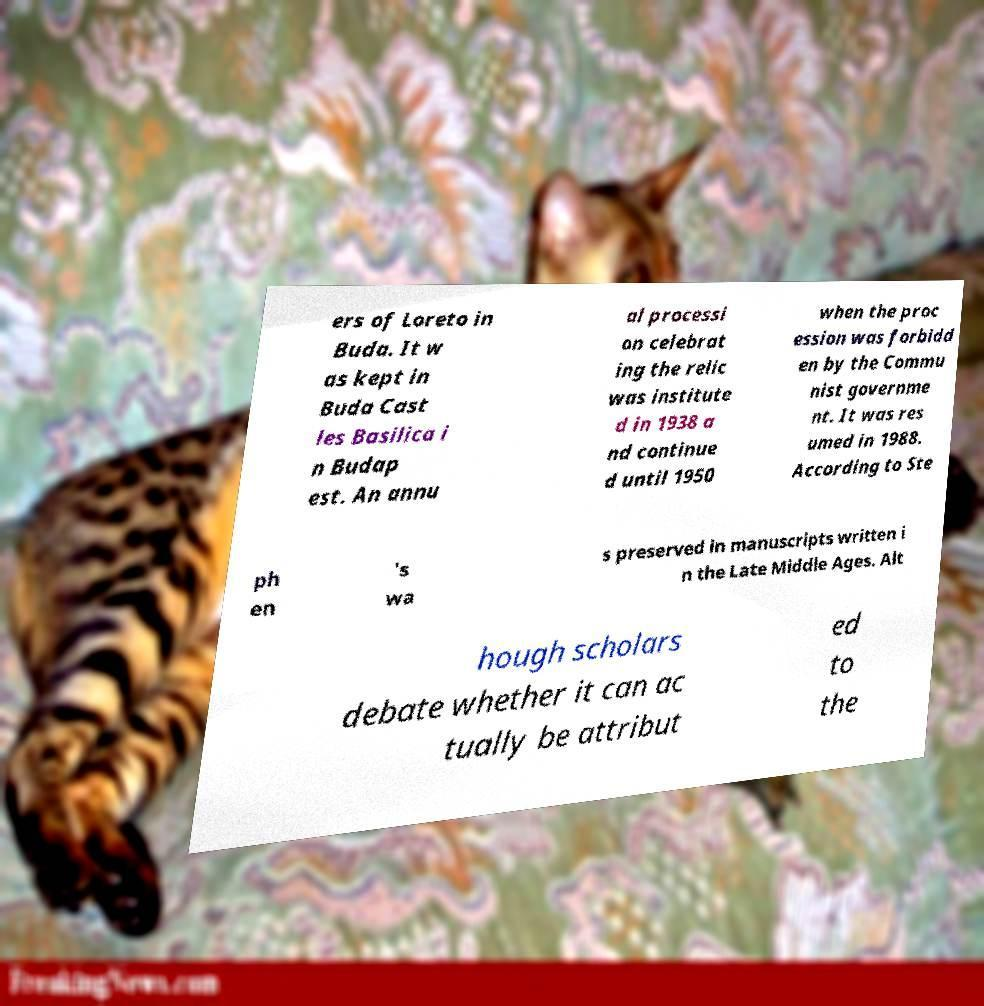Could you assist in decoding the text presented in this image and type it out clearly? ers of Loreto in Buda. It w as kept in Buda Cast les Basilica i n Budap est. An annu al processi on celebrat ing the relic was institute d in 1938 a nd continue d until 1950 when the proc ession was forbidd en by the Commu nist governme nt. It was res umed in 1988. According to Ste ph en 's wa s preserved in manuscripts written i n the Late Middle Ages. Alt hough scholars debate whether it can ac tually be attribut ed to the 